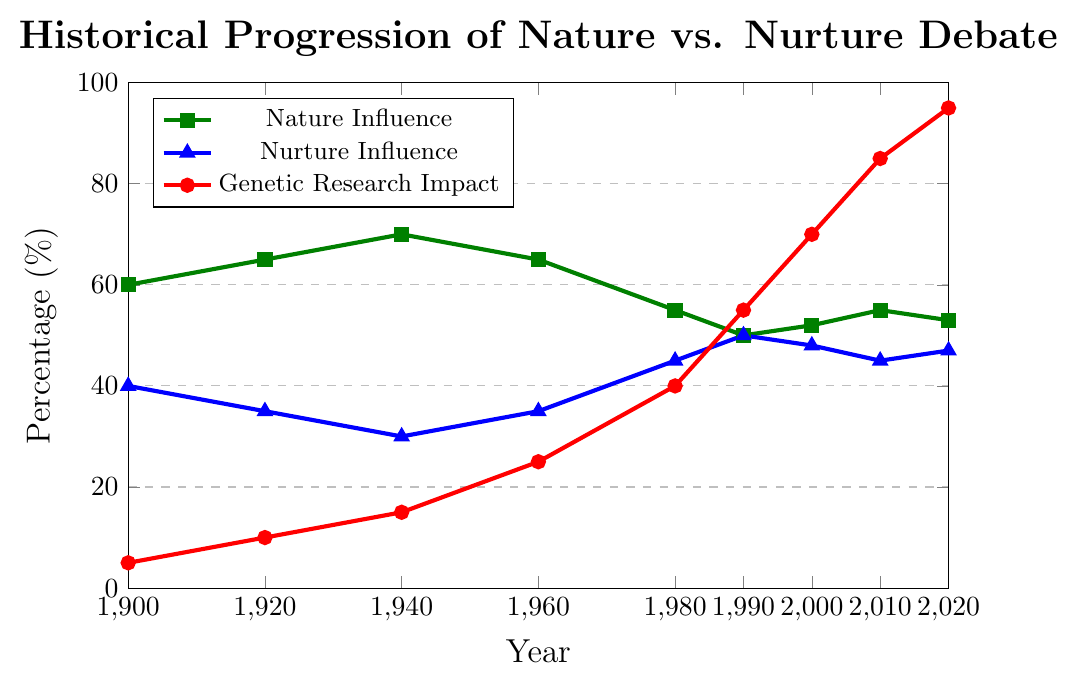Which year saw the highest influence of nature in the nature vs. nurture debate? The figure shows the nature influence percentage for each year. The highest value is 70% in 1940.
Answer: 1940 How did the influence of nurture change between 1980 and 2000? To find the change, subtract the nurture influence percentage in 1980 from that in 2000. The difference is \(48\% - 45\% = 3\%\).
Answer: Increased by 3% In which year was the impact of genetic research equal to 40%? The red line representing genetic research impact reaches 40% in 1980.
Answer: 1980 Compare the influence of nature vs. nurture in 1920. Which one was higher and by how much? Calculate the difference between nature and nurture influences in 1920. The nature influence was 65%, and nurture was 35%, so the difference is \(65\% - 35\% = 30\%\).
Answer: Nature by 30% What trend can be observed for genetic research impact from 1900 to 2020? Observing the red line over the years, it shows a consistently increasing trend from 5% in 1900 to 95% in 2020.
Answer: Increasing trend Which year shows nature and nurture having equal influence, and what was the impact of genetic research that year? The nature and nurture influences are both 50% in 1990. The genetic research impact in 1990 was 55%.
Answer: 1990, 55% Was there any period where the influence of nurture was higher than nature? If yes, when? By scanning across the years, there is no period where the blue line representing nurture influence is higher than the green line representing nature influence.
Answer: No Determine the average genetic research impact over the period 2000 to 2020. Add the values for the years 2000, 2010, and 2020: \(70\% + 85\% + 95\% = 250\%\), then divide by 3 gives \( \frac{250}{3} \approx 83.33\%\).
Answer: 83.33% How did the influence of nature change from 1940 to 1960? Calculate the difference between nature influence in 1940 and 1960. The value in 1940 was 70%, and in 1960 it was 65%, so the change is \(70\% - 65\% = 5\%\).
Answer: Decreased by 5% Visual comparison: In terms of visual attributes, which year shows the most significant change in the slope of the genetic research impact curve, indicating a rapid increase? From the steepest slope in the red line, the most significant increase appears between 1980 and 1990.
Answer: Between 1980 and 1990 